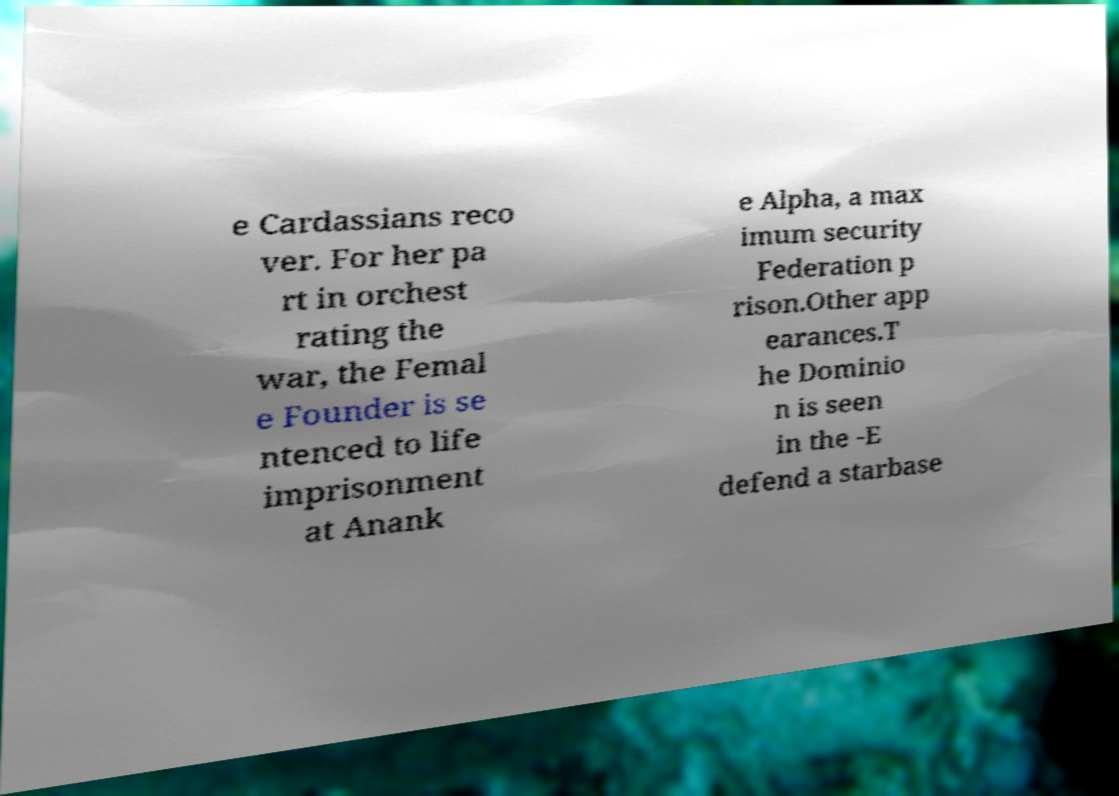Could you assist in decoding the text presented in this image and type it out clearly? e Cardassians reco ver. For her pa rt in orchest rating the war, the Femal e Founder is se ntenced to life imprisonment at Anank e Alpha, a max imum security Federation p rison.Other app earances.T he Dominio n is seen in the -E defend a starbase 